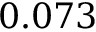<formula> <loc_0><loc_0><loc_500><loc_500>0 . 0 7 3</formula> 